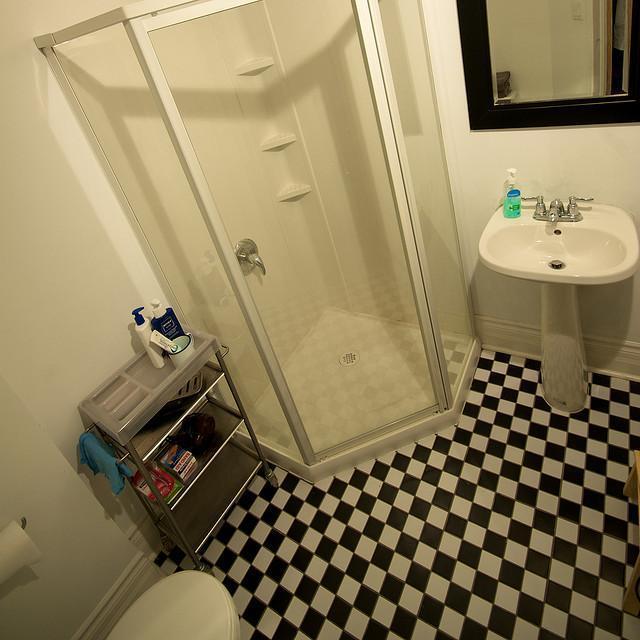How many toilets can be seen?
Give a very brief answer. 1. 